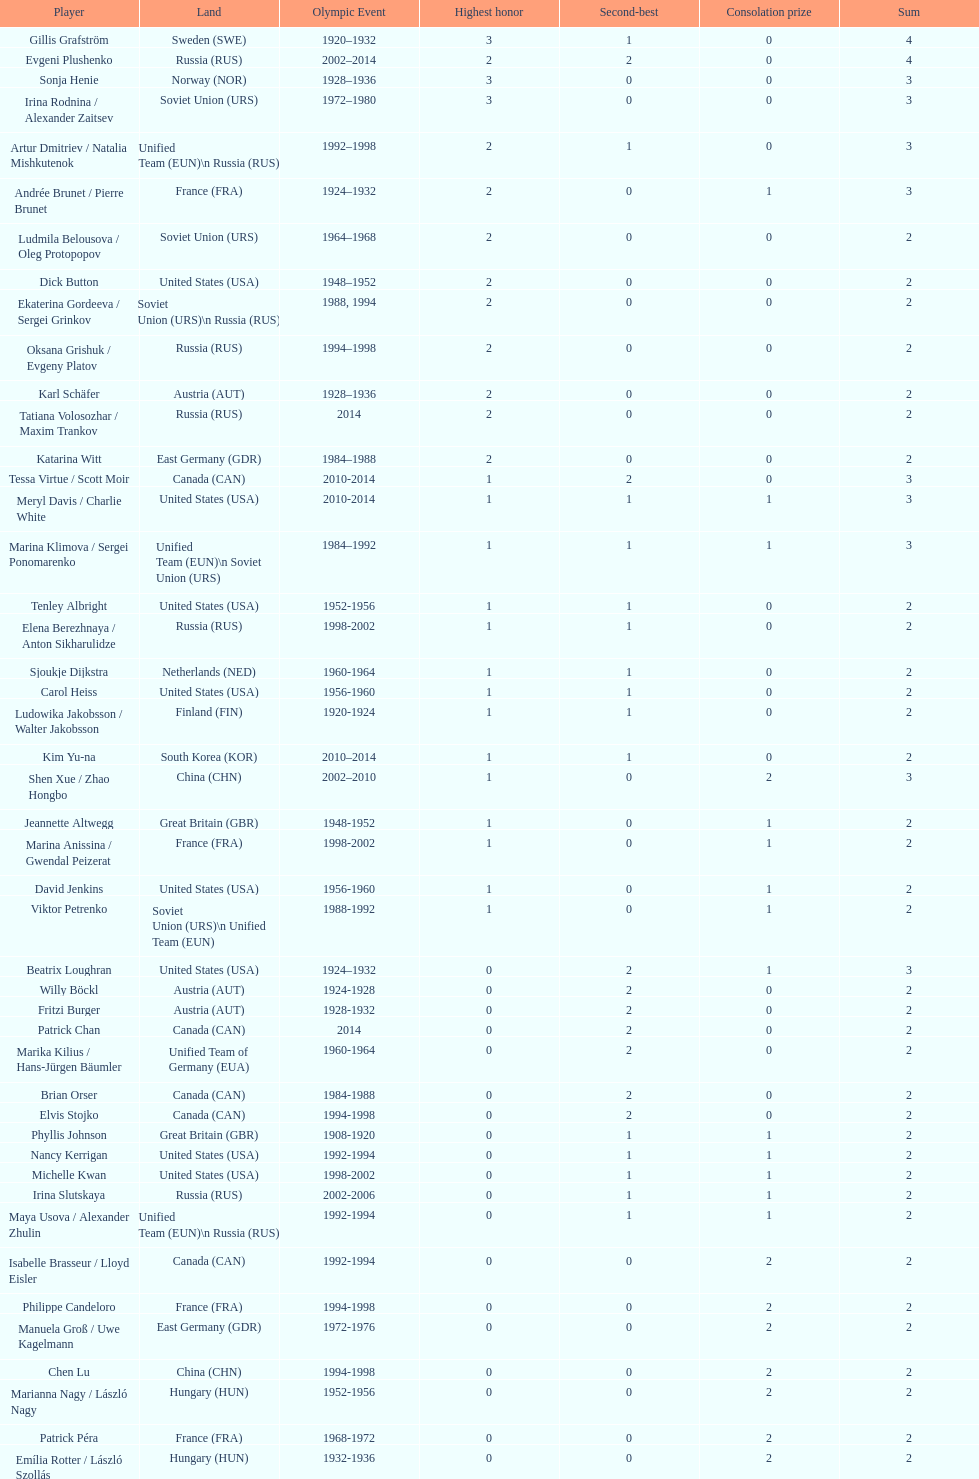What was the greatest number of gold medals won by a single athlete? 3. Would you mind parsing the complete table? {'header': ['Player', 'Land', 'Olympic Event', 'Highest honor', 'Second-best', 'Consolation prize', 'Sum'], 'rows': [['Gillis Grafström', 'Sweden\xa0(SWE)', '1920–1932', '3', '1', '0', '4'], ['Evgeni Plushenko', 'Russia\xa0(RUS)', '2002–2014', '2', '2', '0', '4'], ['Sonja Henie', 'Norway\xa0(NOR)', '1928–1936', '3', '0', '0', '3'], ['Irina Rodnina / Alexander Zaitsev', 'Soviet Union\xa0(URS)', '1972–1980', '3', '0', '0', '3'], ['Artur Dmitriev / Natalia Mishkutenok', 'Unified Team\xa0(EUN)\\n\xa0Russia\xa0(RUS)', '1992–1998', '2', '1', '0', '3'], ['Andrée Brunet / Pierre Brunet', 'France\xa0(FRA)', '1924–1932', '2', '0', '1', '3'], ['Ludmila Belousova / Oleg Protopopov', 'Soviet Union\xa0(URS)', '1964–1968', '2', '0', '0', '2'], ['Dick Button', 'United States\xa0(USA)', '1948–1952', '2', '0', '0', '2'], ['Ekaterina Gordeeva / Sergei Grinkov', 'Soviet Union\xa0(URS)\\n\xa0Russia\xa0(RUS)', '1988, 1994', '2', '0', '0', '2'], ['Oksana Grishuk / Evgeny Platov', 'Russia\xa0(RUS)', '1994–1998', '2', '0', '0', '2'], ['Karl Schäfer', 'Austria\xa0(AUT)', '1928–1936', '2', '0', '0', '2'], ['Tatiana Volosozhar / Maxim Trankov', 'Russia\xa0(RUS)', '2014', '2', '0', '0', '2'], ['Katarina Witt', 'East Germany\xa0(GDR)', '1984–1988', '2', '0', '0', '2'], ['Tessa Virtue / Scott Moir', 'Canada\xa0(CAN)', '2010-2014', '1', '2', '0', '3'], ['Meryl Davis / Charlie White', 'United States\xa0(USA)', '2010-2014', '1', '1', '1', '3'], ['Marina Klimova / Sergei Ponomarenko', 'Unified Team\xa0(EUN)\\n\xa0Soviet Union\xa0(URS)', '1984–1992', '1', '1', '1', '3'], ['Tenley Albright', 'United States\xa0(USA)', '1952-1956', '1', '1', '0', '2'], ['Elena Berezhnaya / Anton Sikharulidze', 'Russia\xa0(RUS)', '1998-2002', '1', '1', '0', '2'], ['Sjoukje Dijkstra', 'Netherlands\xa0(NED)', '1960-1964', '1', '1', '0', '2'], ['Carol Heiss', 'United States\xa0(USA)', '1956-1960', '1', '1', '0', '2'], ['Ludowika Jakobsson / Walter Jakobsson', 'Finland\xa0(FIN)', '1920-1924', '1', '1', '0', '2'], ['Kim Yu-na', 'South Korea\xa0(KOR)', '2010–2014', '1', '1', '0', '2'], ['Shen Xue / Zhao Hongbo', 'China\xa0(CHN)', '2002–2010', '1', '0', '2', '3'], ['Jeannette Altwegg', 'Great Britain\xa0(GBR)', '1948-1952', '1', '0', '1', '2'], ['Marina Anissina / Gwendal Peizerat', 'France\xa0(FRA)', '1998-2002', '1', '0', '1', '2'], ['David Jenkins', 'United States\xa0(USA)', '1956-1960', '1', '0', '1', '2'], ['Viktor Petrenko', 'Soviet Union\xa0(URS)\\n\xa0Unified Team\xa0(EUN)', '1988-1992', '1', '0', '1', '2'], ['Beatrix Loughran', 'United States\xa0(USA)', '1924–1932', '0', '2', '1', '3'], ['Willy Böckl', 'Austria\xa0(AUT)', '1924-1928', '0', '2', '0', '2'], ['Fritzi Burger', 'Austria\xa0(AUT)', '1928-1932', '0', '2', '0', '2'], ['Patrick Chan', 'Canada\xa0(CAN)', '2014', '0', '2', '0', '2'], ['Marika Kilius / Hans-Jürgen Bäumler', 'Unified Team of Germany\xa0(EUA)', '1960-1964', '0', '2', '0', '2'], ['Brian Orser', 'Canada\xa0(CAN)', '1984-1988', '0', '2', '0', '2'], ['Elvis Stojko', 'Canada\xa0(CAN)', '1994-1998', '0', '2', '0', '2'], ['Phyllis Johnson', 'Great Britain\xa0(GBR)', '1908-1920', '0', '1', '1', '2'], ['Nancy Kerrigan', 'United States\xa0(USA)', '1992-1994', '0', '1', '1', '2'], ['Michelle Kwan', 'United States\xa0(USA)', '1998-2002', '0', '1', '1', '2'], ['Irina Slutskaya', 'Russia\xa0(RUS)', '2002-2006', '0', '1', '1', '2'], ['Maya Usova / Alexander Zhulin', 'Unified Team\xa0(EUN)\\n\xa0Russia\xa0(RUS)', '1992-1994', '0', '1', '1', '2'], ['Isabelle Brasseur / Lloyd Eisler', 'Canada\xa0(CAN)', '1992-1994', '0', '0', '2', '2'], ['Philippe Candeloro', 'France\xa0(FRA)', '1994-1998', '0', '0', '2', '2'], ['Manuela Groß / Uwe Kagelmann', 'East Germany\xa0(GDR)', '1972-1976', '0', '0', '2', '2'], ['Chen Lu', 'China\xa0(CHN)', '1994-1998', '0', '0', '2', '2'], ['Marianna Nagy / László Nagy', 'Hungary\xa0(HUN)', '1952-1956', '0', '0', '2', '2'], ['Patrick Péra', 'France\xa0(FRA)', '1968-1972', '0', '0', '2', '2'], ['Emília Rotter / László Szollás', 'Hungary\xa0(HUN)', '1932-1936', '0', '0', '2', '2'], ['Aliona Savchenko / Robin Szolkowy', 'Germany\xa0(GER)', '2010-2014', '0', '0', '2', '2']]} 